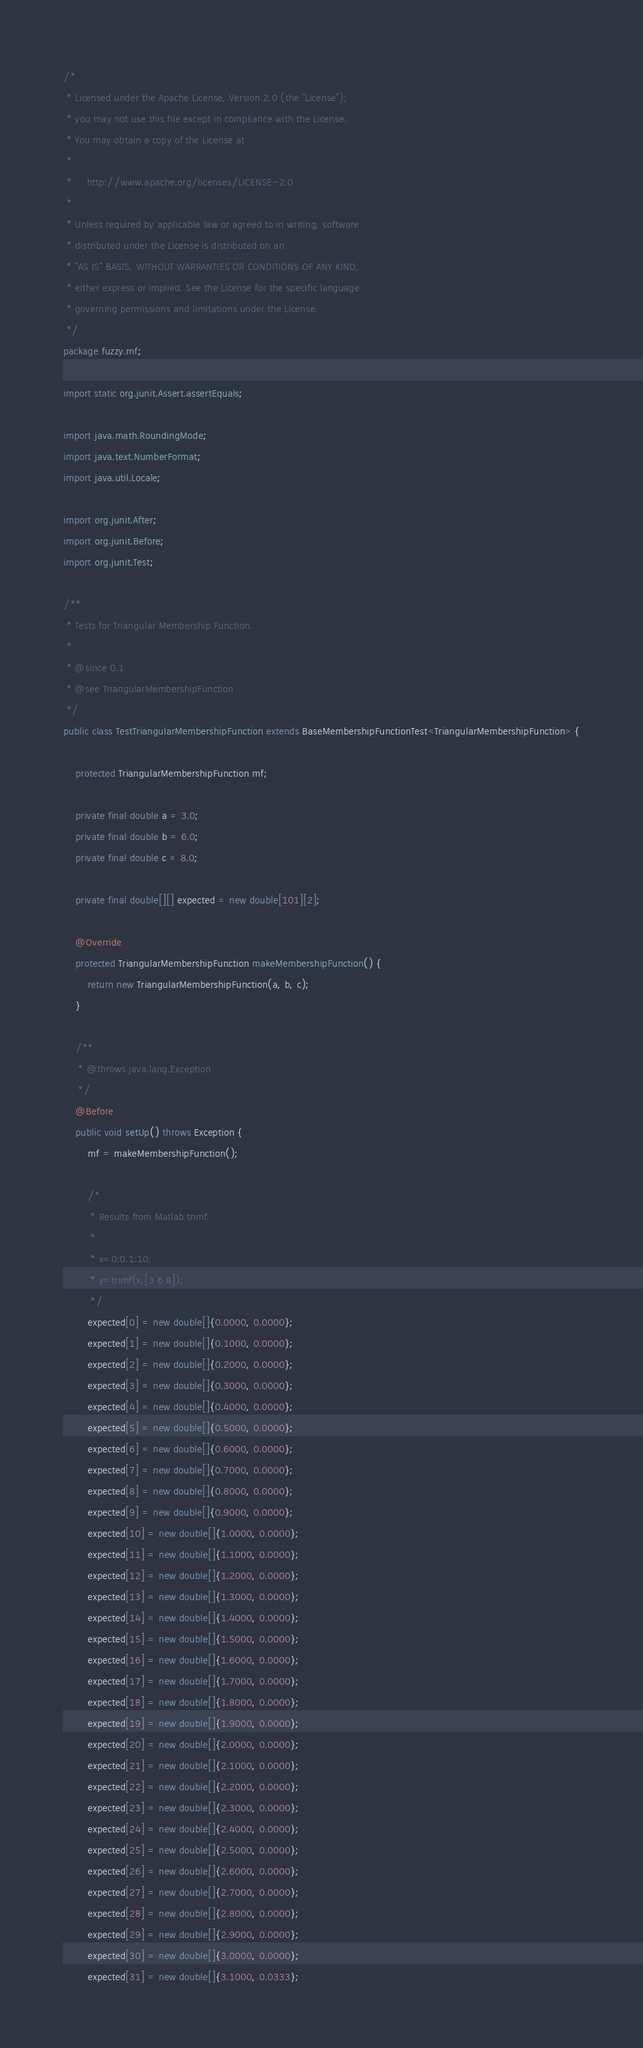Convert code to text. <code><loc_0><loc_0><loc_500><loc_500><_Java_>/*
 * Licensed under the Apache License, Version 2.0 (the "License");
 * you may not use this file except in compliance with the License.
 * You may obtain a copy of the License at
 *
 *     http://www.apache.org/licenses/LICENSE-2.0
 *
 * Unless required by applicable law or agreed to in writing, software
 * distributed under the License is distributed on an
 * "AS IS" BASIS, WITHOUT WARRANTIES OR CONDITIONS OF ANY KIND,
 * either express or implied. See the License for the specific language
 * governing permissions and limitations under the License.
 */
package fuzzy.mf;

import static org.junit.Assert.assertEquals;

import java.math.RoundingMode;
import java.text.NumberFormat;
import java.util.Locale;

import org.junit.After;
import org.junit.Before;
import org.junit.Test;

/**
 * Tests for Triangular Membership Function.
 *
 * @since 0.1
 * @see TriangularMembershipFunction
 */
public class TestTriangularMembershipFunction extends BaseMembershipFunctionTest<TriangularMembershipFunction> {

	protected TriangularMembershipFunction mf;

	private final double a = 3.0;
	private final double b = 6.0;
	private final double c = 8.0;

	private final double[][] expected = new double[101][2];

	@Override
	protected TriangularMembershipFunction makeMembershipFunction() {
		return new TriangularMembershipFunction(a, b, c);
	}

	/**
	 * @throws java.lang.Exception
	 */
	@Before
	public void setUp() throws Exception {
		mf = makeMembershipFunction();

		/*
		 * Results from Matlab trimf.
		 *
		 * x=0:0.1:10;
		 * y=trimf(x,[3 6 8]);
		 */
		expected[0] = new double[]{0.0000, 0.0000};
		expected[1] = new double[]{0.1000, 0.0000};
		expected[2] = new double[]{0.2000, 0.0000};
		expected[3] = new double[]{0.3000, 0.0000};
		expected[4] = new double[]{0.4000, 0.0000};
		expected[5] = new double[]{0.5000, 0.0000};
		expected[6] = new double[]{0.6000, 0.0000};
		expected[7] = new double[]{0.7000, 0.0000};
		expected[8] = new double[]{0.8000, 0.0000};
		expected[9] = new double[]{0.9000, 0.0000};
		expected[10] = new double[]{1.0000, 0.0000};
		expected[11] = new double[]{1.1000, 0.0000};
		expected[12] = new double[]{1.2000, 0.0000};
		expected[13] = new double[]{1.3000, 0.0000};
		expected[14] = new double[]{1.4000, 0.0000};
		expected[15] = new double[]{1.5000, 0.0000};
		expected[16] = new double[]{1.6000, 0.0000};
		expected[17] = new double[]{1.7000, 0.0000};
		expected[18] = new double[]{1.8000, 0.0000};
		expected[19] = new double[]{1.9000, 0.0000};
		expected[20] = new double[]{2.0000, 0.0000};
		expected[21] = new double[]{2.1000, 0.0000};
		expected[22] = new double[]{2.2000, 0.0000};
		expected[23] = new double[]{2.3000, 0.0000};
		expected[24] = new double[]{2.4000, 0.0000};
		expected[25] = new double[]{2.5000, 0.0000};
		expected[26] = new double[]{2.6000, 0.0000};
		expected[27] = new double[]{2.7000, 0.0000};
		expected[28] = new double[]{2.8000, 0.0000};
		expected[29] = new double[]{2.9000, 0.0000};
		expected[30] = new double[]{3.0000, 0.0000};
		expected[31] = new double[]{3.1000, 0.0333};</code> 